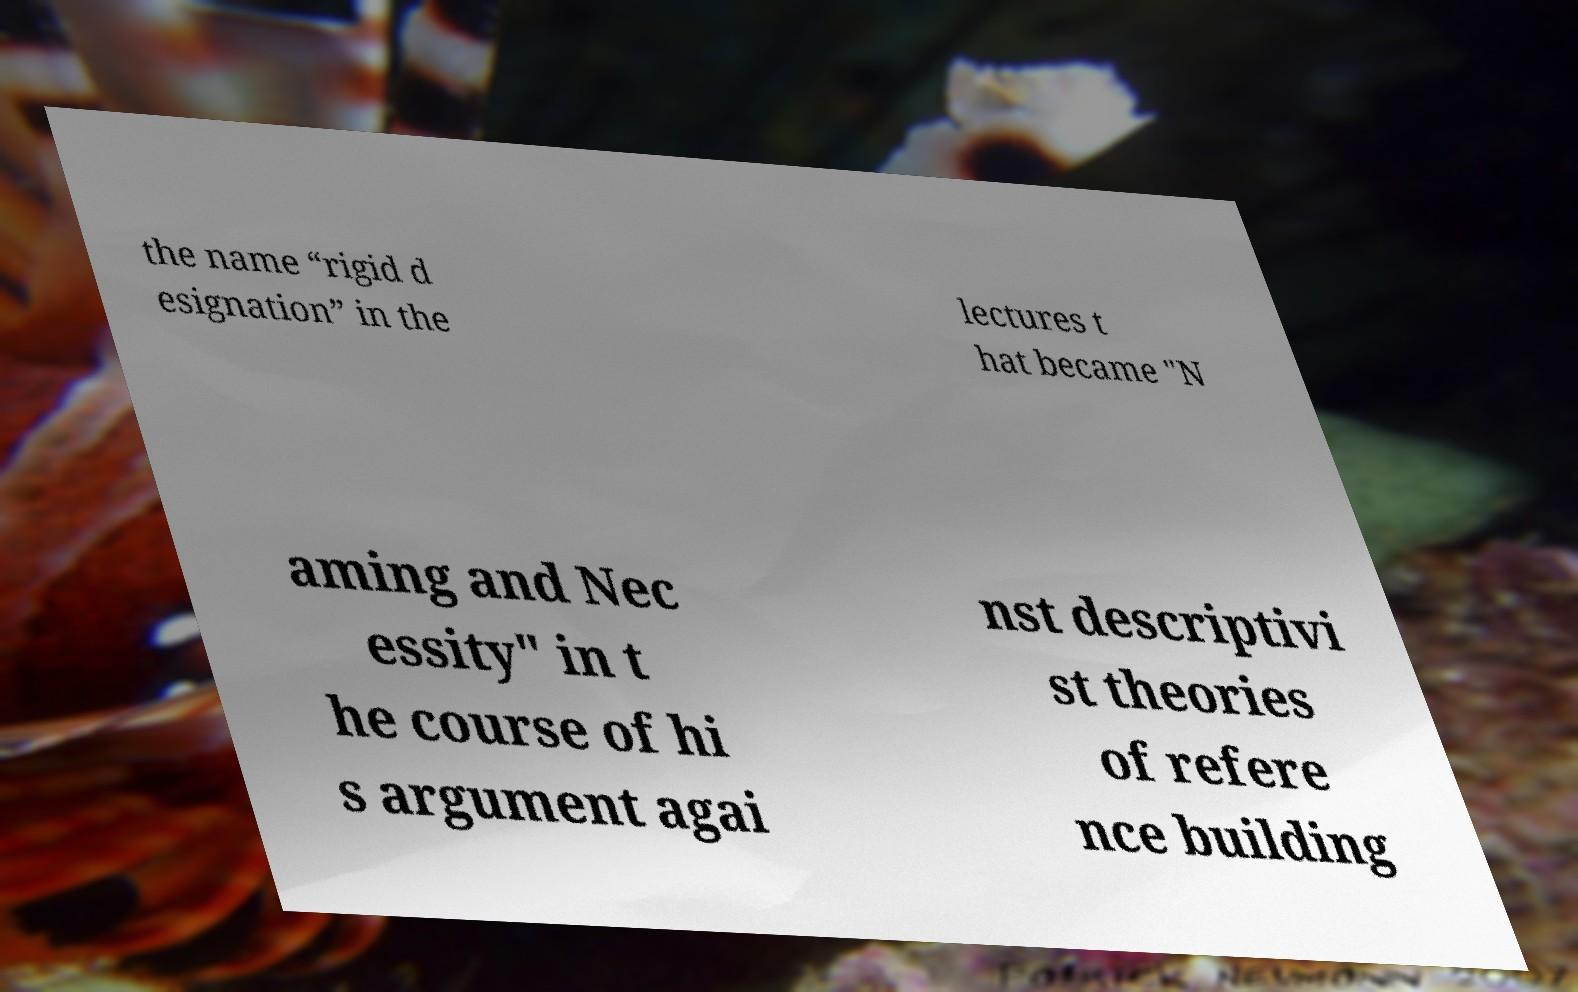Please identify and transcribe the text found in this image. the name “rigid d esignation” in the lectures t hat became "N aming and Nec essity" in t he course of hi s argument agai nst descriptivi st theories of refere nce building 